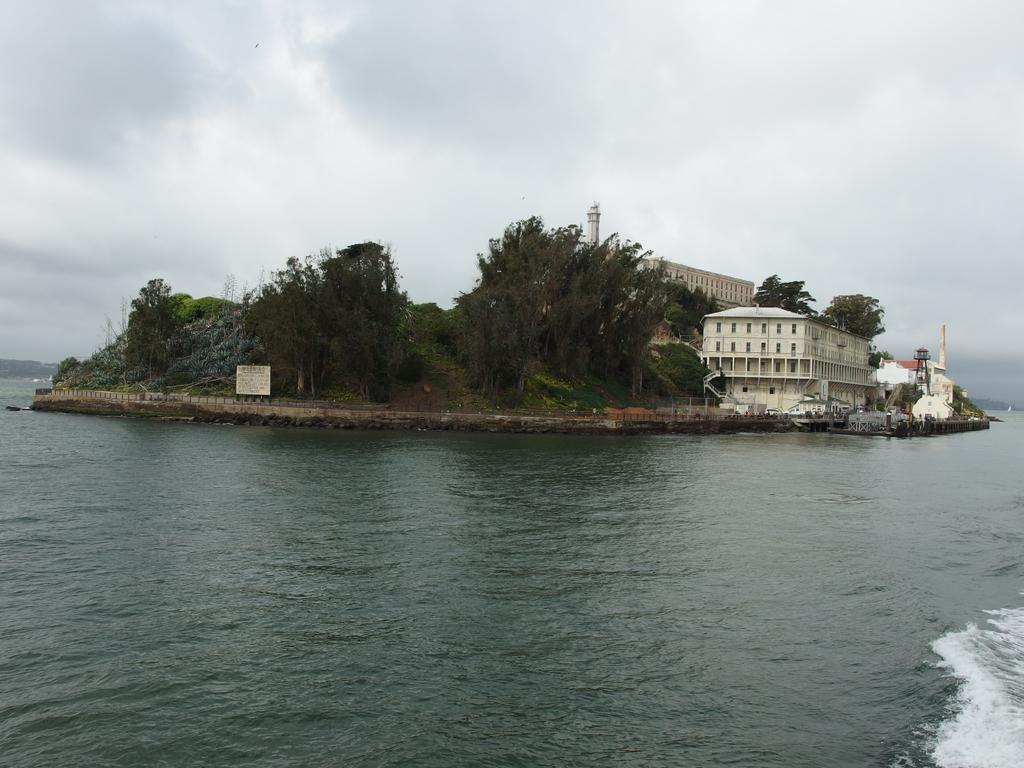How would you summarize this image in a sentence or two? At the bottom there is water, in the middle there are trees. On the right side there are houses, at the top it is the cloudy sky. 